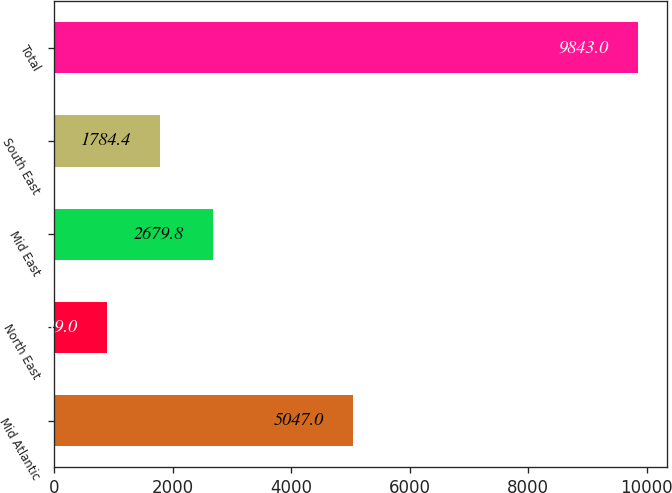<chart> <loc_0><loc_0><loc_500><loc_500><bar_chart><fcel>Mid Atlantic<fcel>North East<fcel>Mid East<fcel>South East<fcel>Total<nl><fcel>5047<fcel>889<fcel>2679.8<fcel>1784.4<fcel>9843<nl></chart> 